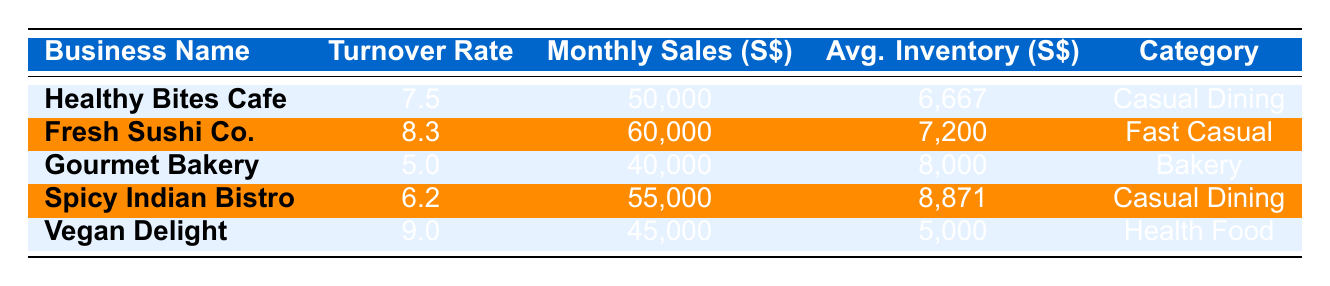What is the inventory turnover rate for Vegan Delight? The table shows the inventory turnover rate for each business. For Vegan Delight, it is listed directly in the row corresponding to that business.
Answer: 9.0 Which business has the highest monthly sales? By comparing the monthly sales figures in the table, Fresh Sushi Co. (60,000) has the highest value among all listed businesses.
Answer: Fresh Sushi Co What is the average inventory for Healthy Bites Cafe? The average inventory amount is specifically provided in the table under the column for Average Inventory for Healthy Bites Cafe, which is indicated as 6,667.
Answer: 6,667 What is the difference in inventory turnover rates between Fresh Sushi Co. and Gourmet Bakery? To find the difference, subtract Gourmet Bakery's turnover rate (5.0) from Fresh Sushi Co.'s rate (8.3). So, 8.3 - 5.0 = 3.3.
Answer: 3.3 Is the average inventory for Spicy Indian Bistro higher than 8,000? The average inventory value for Spicy Indian Bistro is explicitly given in the table as 8,871, which is indeed higher than 8,000.
Answer: Yes Which category does Vegan Delight belong to, and how does its turnover rate compare to the average turnover rate of all the businesses? Vegan Delight belongs to the Health Food category, and its turnover rate is 9.0. To find the average turnover rate, calculate the turnover rates: (7.5 + 8.3 + 5.0 + 6.2 + 9.0) / 5 = 7.0. Since 9.0 is greater than 7.0, Vegan Delight has a higher turnover rate than the average.
Answer: Higher than average What is the lowest inventory turnover rate in the table? Review the turnover rates for all businesses to find the lowest value. Gourmet Bakery has the lowest turnover rate at 5.0.
Answer: 5.0 If the total monthly sales from all businesses are combined, what will be the total? The total monthly sales are found by adding the sales from all businesses: 50,000 + 60,000 + 40,000 + 55,000 + 45,000 = 250,000.
Answer: 250,000 Does any business in the Casual Dining category have a turnover rate greater than 7.0? Check the turnover rates for the businesses in the Casual Dining category (Healthy Bites Cafe at 7.5 and Spicy Indian Bistro at 6.2). Only Healthy Bites Cafe is above 7.0.
Answer: Yes 